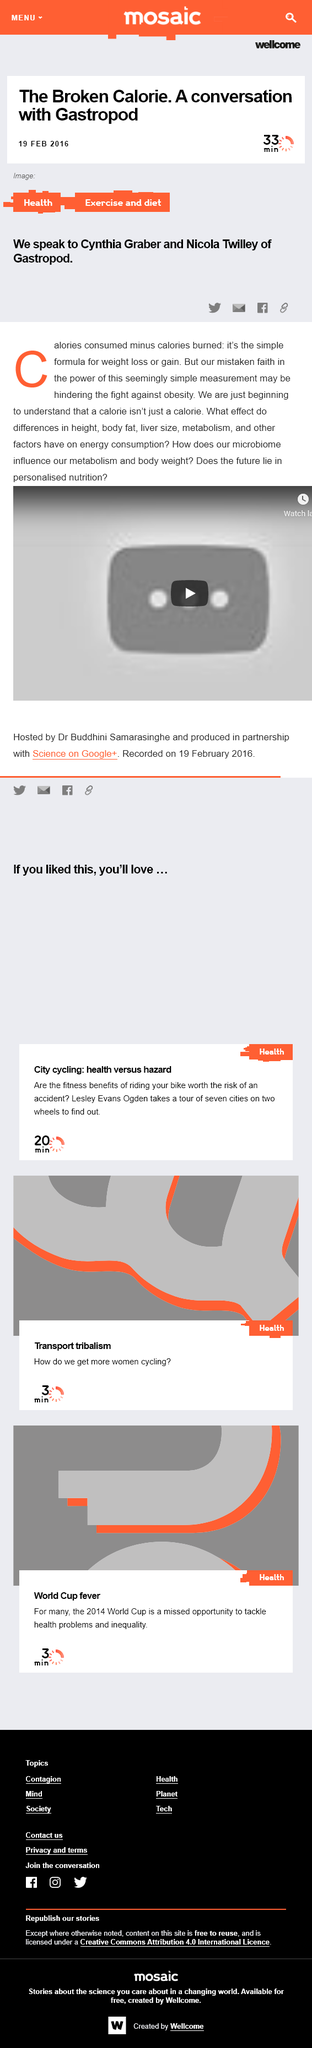Identify some key points in this picture. I declare that there are 4 distinct ways to share the article. The article titled "The Broken Calorie. A Conversation with Gastropod" was published on February 19th, 2016. The article will take approximately 33 minutes to read. 